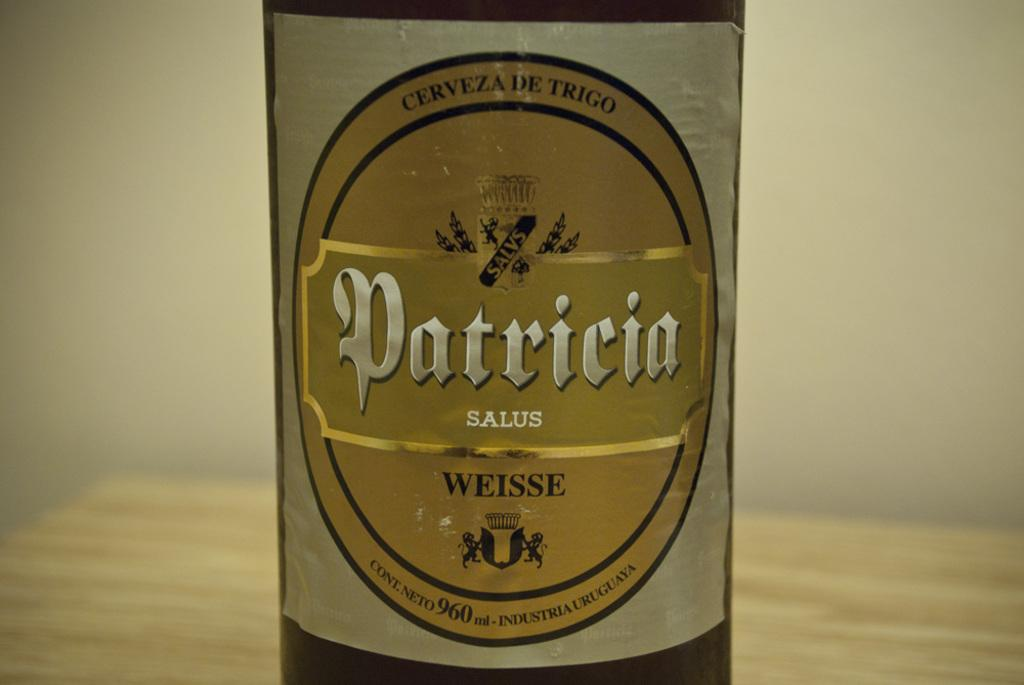<image>
Write a terse but informative summary of the picture. the word Patricia that is on a bottle 